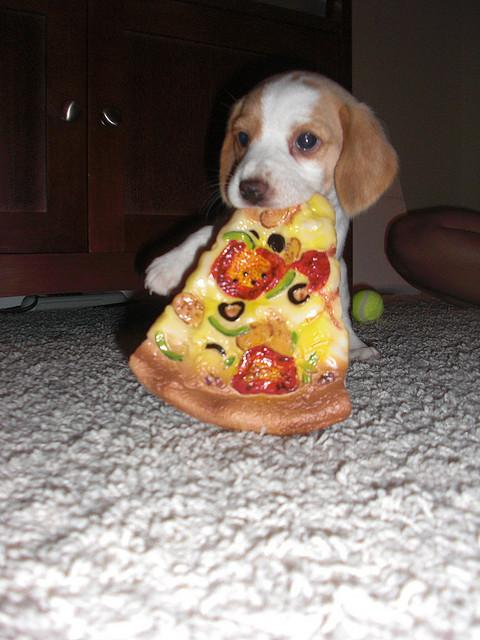What is the dog doing with the thing in its mouth? chewing 